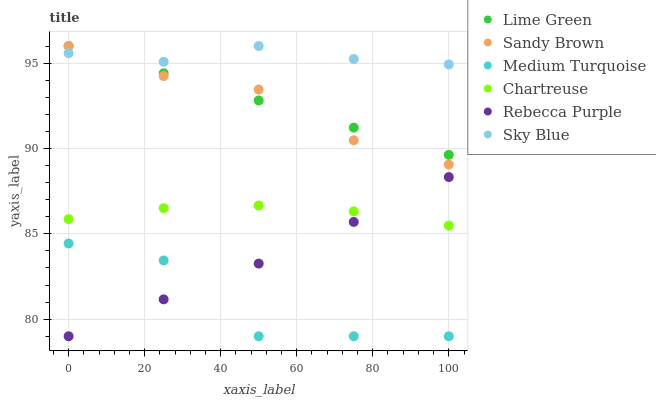Does Medium Turquoise have the minimum area under the curve?
Answer yes or no. Yes. Does Sky Blue have the maximum area under the curve?
Answer yes or no. Yes. Does Chartreuse have the minimum area under the curve?
Answer yes or no. No. Does Chartreuse have the maximum area under the curve?
Answer yes or no. No. Is Lime Green the smoothest?
Answer yes or no. Yes. Is Medium Turquoise the roughest?
Answer yes or no. Yes. Is Chartreuse the smoothest?
Answer yes or no. No. Is Chartreuse the roughest?
Answer yes or no. No. Does Rebecca Purple have the lowest value?
Answer yes or no. Yes. Does Chartreuse have the lowest value?
Answer yes or no. No. Does Sandy Brown have the highest value?
Answer yes or no. Yes. Does Chartreuse have the highest value?
Answer yes or no. No. Is Medium Turquoise less than Lime Green?
Answer yes or no. Yes. Is Lime Green greater than Medium Turquoise?
Answer yes or no. Yes. Does Rebecca Purple intersect Medium Turquoise?
Answer yes or no. Yes. Is Rebecca Purple less than Medium Turquoise?
Answer yes or no. No. Is Rebecca Purple greater than Medium Turquoise?
Answer yes or no. No. Does Medium Turquoise intersect Lime Green?
Answer yes or no. No. 